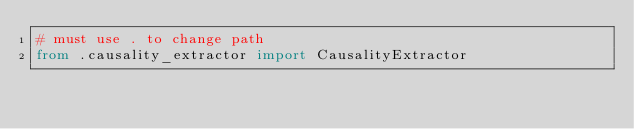Convert code to text. <code><loc_0><loc_0><loc_500><loc_500><_Python_># must use . to change path
from .causality_extractor import CausalityExtractor</code> 